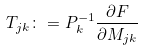<formula> <loc_0><loc_0><loc_500><loc_500>T _ { j k } \colon = P _ { k } ^ { - 1 } \frac { \partial F } { \partial M _ { j k } }</formula> 